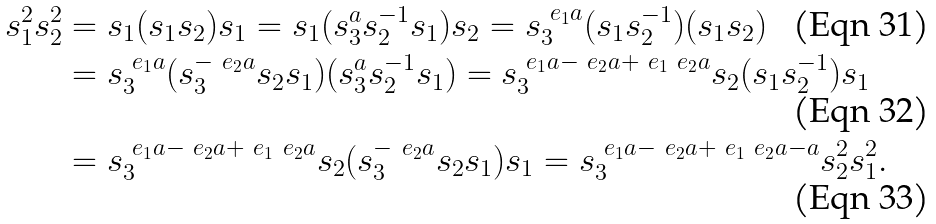<formula> <loc_0><loc_0><loc_500><loc_500>s _ { 1 } ^ { 2 } s _ { 2 } ^ { 2 } & = s _ { 1 } ( s _ { 1 } s _ { 2 } ) s _ { 1 } = s _ { 1 } ( s _ { 3 } ^ { a } s _ { 2 } ^ { - 1 } s _ { 1 } ) s _ { 2 } = s _ { 3 } ^ { \ e _ { 1 } a } ( s _ { 1 } s _ { 2 } ^ { - 1 } ) ( s _ { 1 } s _ { 2 } ) \\ & = s _ { 3 } ^ { \ e _ { 1 } a } ( s _ { 3 } ^ { - \ e _ { 2 } a } s _ { 2 } s _ { 1 } ) ( s _ { 3 } ^ { a } s _ { 2 } ^ { - 1 } s _ { 1 } ) = s _ { 3 } ^ { \ e _ { 1 } a - \ e _ { 2 } a + \ e _ { 1 } \ e _ { 2 } a } s _ { 2 } ( s _ { 1 } s _ { 2 } ^ { - 1 } ) s _ { 1 } \\ & = s _ { 3 } ^ { \ e _ { 1 } a - \ e _ { 2 } a + \ e _ { 1 } \ e _ { 2 } a } s _ { 2 } ( s _ { 3 } ^ { - \ e _ { 2 } a } s _ { 2 } s _ { 1 } ) s _ { 1 } = s _ { 3 } ^ { \ e _ { 1 } a - \ e _ { 2 } a + \ e _ { 1 } \ e _ { 2 } a - a } s _ { 2 } ^ { 2 } s _ { 1 } ^ { 2 } .</formula> 